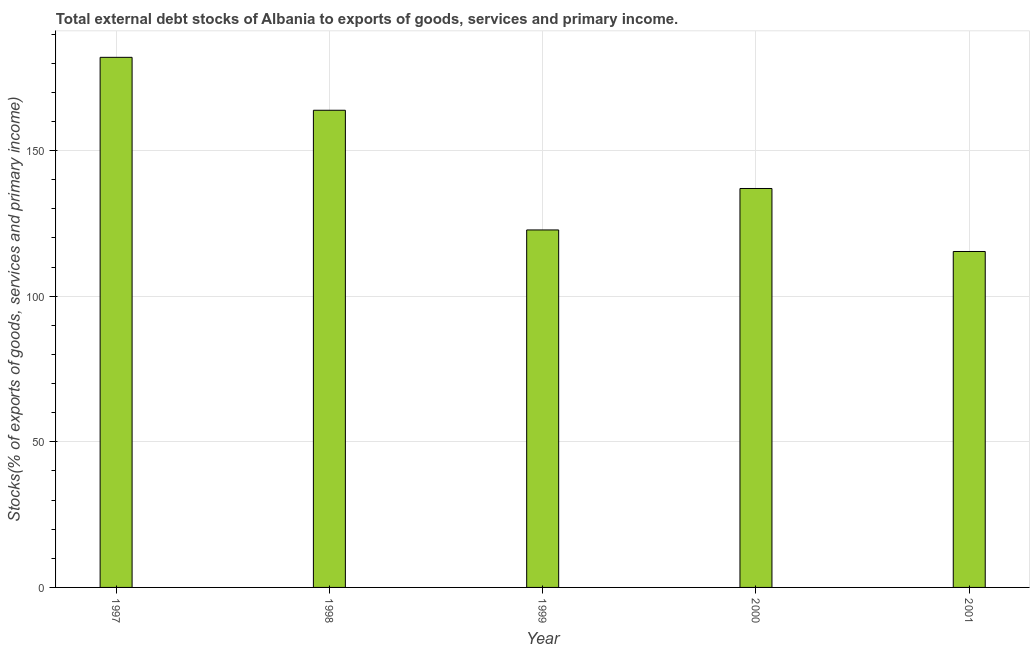Does the graph contain any zero values?
Offer a very short reply. No. What is the title of the graph?
Keep it short and to the point. Total external debt stocks of Albania to exports of goods, services and primary income. What is the label or title of the X-axis?
Your answer should be compact. Year. What is the label or title of the Y-axis?
Your response must be concise. Stocks(% of exports of goods, services and primary income). What is the external debt stocks in 2001?
Your answer should be compact. 115.34. Across all years, what is the maximum external debt stocks?
Provide a succinct answer. 182. Across all years, what is the minimum external debt stocks?
Provide a succinct answer. 115.34. In which year was the external debt stocks maximum?
Give a very brief answer. 1997. In which year was the external debt stocks minimum?
Offer a terse response. 2001. What is the sum of the external debt stocks?
Your response must be concise. 720.86. What is the difference between the external debt stocks in 1997 and 1999?
Your answer should be very brief. 59.27. What is the average external debt stocks per year?
Make the answer very short. 144.17. What is the median external debt stocks?
Your response must be concise. 136.97. In how many years, is the external debt stocks greater than 110 %?
Provide a short and direct response. 5. Do a majority of the years between 1999 and 1997 (inclusive) have external debt stocks greater than 90 %?
Provide a succinct answer. Yes. What is the ratio of the external debt stocks in 1998 to that in 2000?
Give a very brief answer. 1.2. Is the external debt stocks in 1997 less than that in 1999?
Offer a terse response. No. What is the difference between the highest and the second highest external debt stocks?
Provide a short and direct response. 18.17. Is the sum of the external debt stocks in 1999 and 2000 greater than the maximum external debt stocks across all years?
Offer a terse response. Yes. What is the difference between the highest and the lowest external debt stocks?
Offer a very short reply. 66.66. In how many years, is the external debt stocks greater than the average external debt stocks taken over all years?
Provide a short and direct response. 2. How many bars are there?
Your answer should be very brief. 5. What is the Stocks(% of exports of goods, services and primary income) in 1997?
Your answer should be compact. 182. What is the Stocks(% of exports of goods, services and primary income) of 1998?
Your answer should be very brief. 163.83. What is the Stocks(% of exports of goods, services and primary income) of 1999?
Make the answer very short. 122.73. What is the Stocks(% of exports of goods, services and primary income) of 2000?
Your answer should be very brief. 136.97. What is the Stocks(% of exports of goods, services and primary income) of 2001?
Offer a very short reply. 115.34. What is the difference between the Stocks(% of exports of goods, services and primary income) in 1997 and 1998?
Provide a succinct answer. 18.17. What is the difference between the Stocks(% of exports of goods, services and primary income) in 1997 and 1999?
Your answer should be very brief. 59.27. What is the difference between the Stocks(% of exports of goods, services and primary income) in 1997 and 2000?
Keep it short and to the point. 45.03. What is the difference between the Stocks(% of exports of goods, services and primary income) in 1997 and 2001?
Provide a short and direct response. 66.66. What is the difference between the Stocks(% of exports of goods, services and primary income) in 1998 and 1999?
Your answer should be very brief. 41.09. What is the difference between the Stocks(% of exports of goods, services and primary income) in 1998 and 2000?
Your answer should be very brief. 26.86. What is the difference between the Stocks(% of exports of goods, services and primary income) in 1998 and 2001?
Ensure brevity in your answer.  48.49. What is the difference between the Stocks(% of exports of goods, services and primary income) in 1999 and 2000?
Make the answer very short. -14.23. What is the difference between the Stocks(% of exports of goods, services and primary income) in 1999 and 2001?
Keep it short and to the point. 7.4. What is the difference between the Stocks(% of exports of goods, services and primary income) in 2000 and 2001?
Keep it short and to the point. 21.63. What is the ratio of the Stocks(% of exports of goods, services and primary income) in 1997 to that in 1998?
Offer a very short reply. 1.11. What is the ratio of the Stocks(% of exports of goods, services and primary income) in 1997 to that in 1999?
Offer a very short reply. 1.48. What is the ratio of the Stocks(% of exports of goods, services and primary income) in 1997 to that in 2000?
Offer a very short reply. 1.33. What is the ratio of the Stocks(% of exports of goods, services and primary income) in 1997 to that in 2001?
Your response must be concise. 1.58. What is the ratio of the Stocks(% of exports of goods, services and primary income) in 1998 to that in 1999?
Offer a terse response. 1.33. What is the ratio of the Stocks(% of exports of goods, services and primary income) in 1998 to that in 2000?
Make the answer very short. 1.2. What is the ratio of the Stocks(% of exports of goods, services and primary income) in 1998 to that in 2001?
Ensure brevity in your answer.  1.42. What is the ratio of the Stocks(% of exports of goods, services and primary income) in 1999 to that in 2000?
Ensure brevity in your answer.  0.9. What is the ratio of the Stocks(% of exports of goods, services and primary income) in 1999 to that in 2001?
Provide a short and direct response. 1.06. What is the ratio of the Stocks(% of exports of goods, services and primary income) in 2000 to that in 2001?
Offer a terse response. 1.19. 